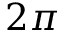<formula> <loc_0><loc_0><loc_500><loc_500>2 \pi</formula> 